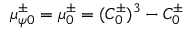<formula> <loc_0><loc_0><loc_500><loc_500>\mu _ { \psi 0 } ^ { \pm } = \mu _ { 0 } ^ { \pm } = ( C _ { 0 } ^ { \pm } ) ^ { 3 } - C _ { 0 } ^ { \pm }</formula> 